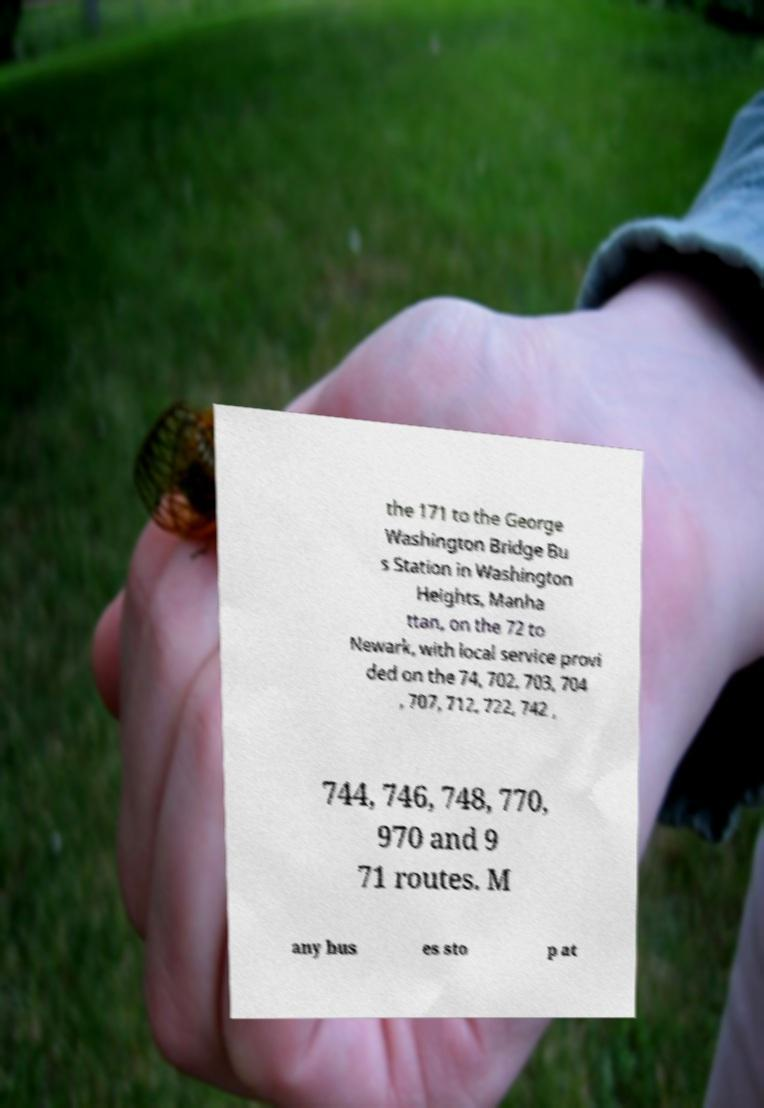Can you accurately transcribe the text from the provided image for me? the 171 to the George Washington Bridge Bu s Station in Washington Heights, Manha ttan, on the 72 to Newark, with local service provi ded on the 74, 702, 703, 704 , 707, 712, 722, 742 , 744, 746, 748, 770, 970 and 9 71 routes. M any bus es sto p at 